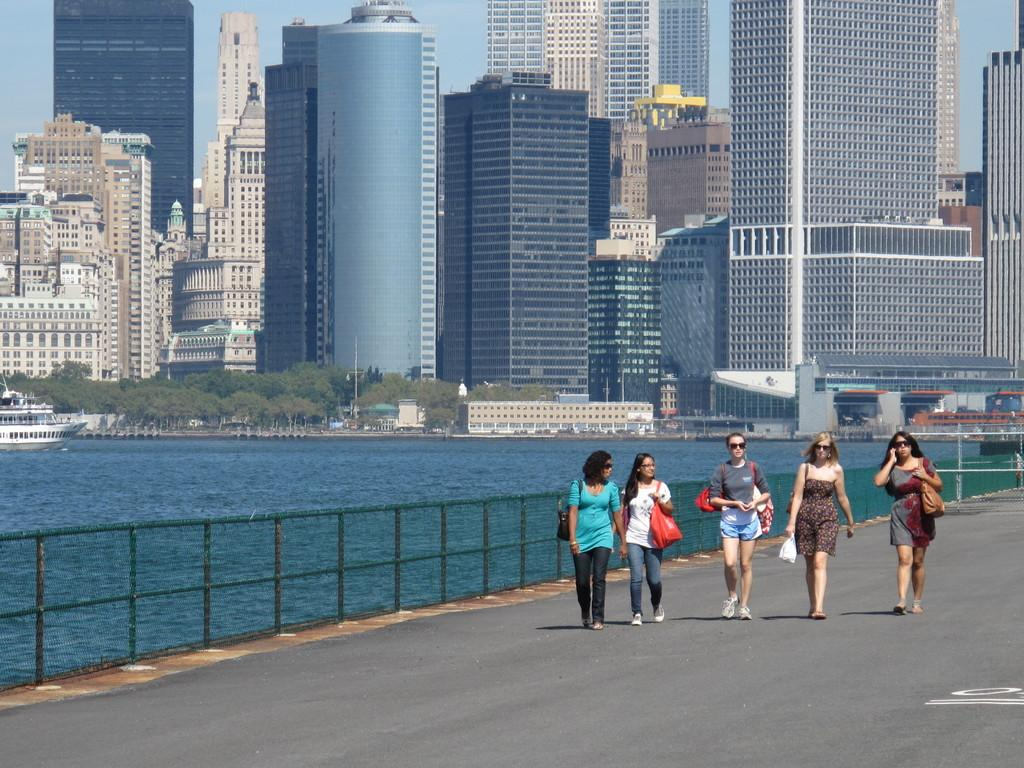What are the women in the image doing? The women in the image are walking on the road. What natural feature can be seen in the image? There is a lake in the image. What can be seen in the background of the image? There are buildings in the background of the image. What type of vegetation is present in front of the buildings? Trees are present in front of the buildings. What is visible above the scene in the image? The sky is visible above the scene. What type of quill is being used by the women in the image? There is no quill present in the image; the women are walking on the road. 